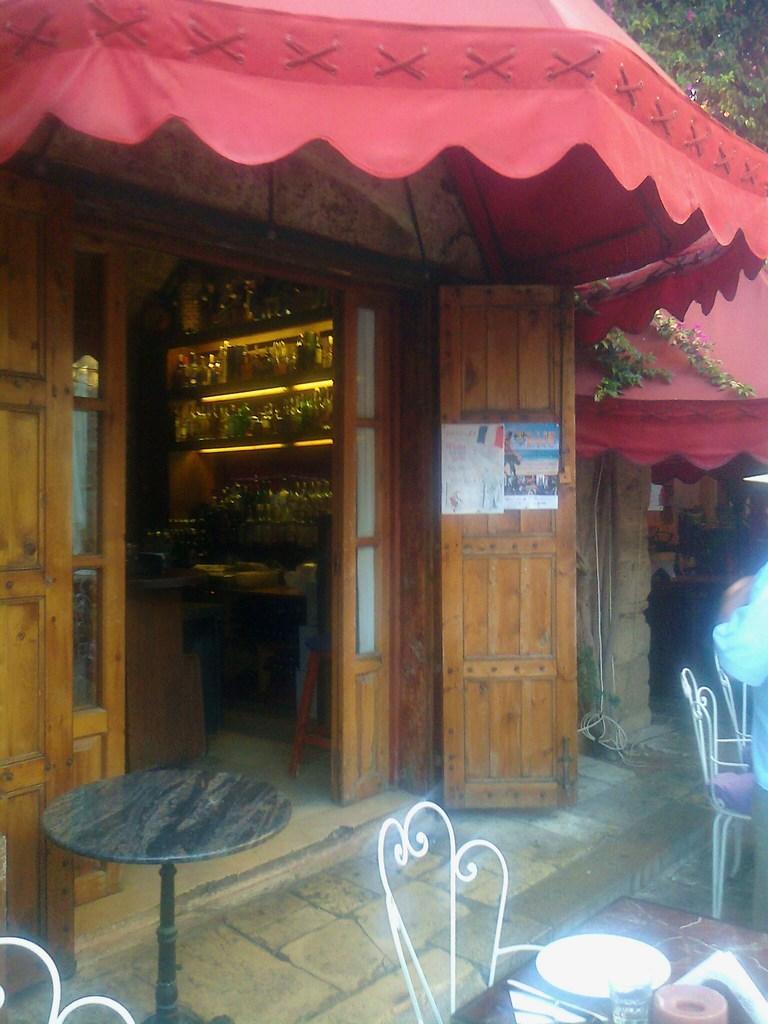Please provide a concise description of this image. In this image, we can see some tables and chairs, on the right side, we can see a person. In the background, we can see a door, tent. In the room, we can also see a shelf with some bottles. 